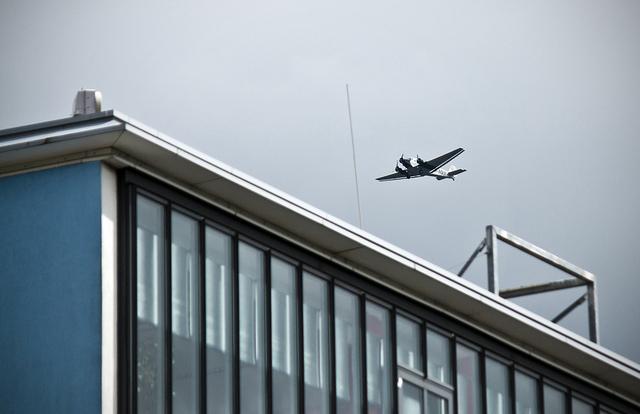Is there a door in this picture?
Answer briefly. No. What is the plane flying over?
Keep it brief. Building. What direction is the plane pointing?
Give a very brief answer. East. 